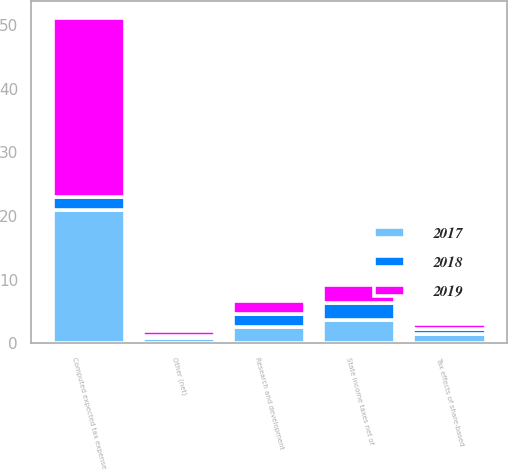<chart> <loc_0><loc_0><loc_500><loc_500><stacked_bar_chart><ecel><fcel>Computed expected tax expense<fcel>State income taxes net of<fcel>Research and development<fcel>Tax effects of share-based<fcel>Other (net)<nl><fcel>2017<fcel>21<fcel>3.7<fcel>2.5<fcel>1.4<fcel>0.9<nl><fcel>2019<fcel>28.1<fcel>2.9<fcel>2<fcel>0.8<fcel>0.7<nl><fcel>2018<fcel>2.05<fcel>2.6<fcel>2.1<fcel>0.8<fcel>0.3<nl></chart> 